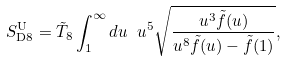Convert formula to latex. <formula><loc_0><loc_0><loc_500><loc_500>S _ { \text {D8} } ^ { \text {U} } = \tilde { T } _ { 8 } \int _ { 1 } ^ { \infty } d u \ u ^ { 5 } \sqrt { \frac { u ^ { 3 } \tilde { f } ( u ) } { u ^ { 8 } \tilde { f } ( u ) - \tilde { f } ( 1 ) } } ,</formula> 